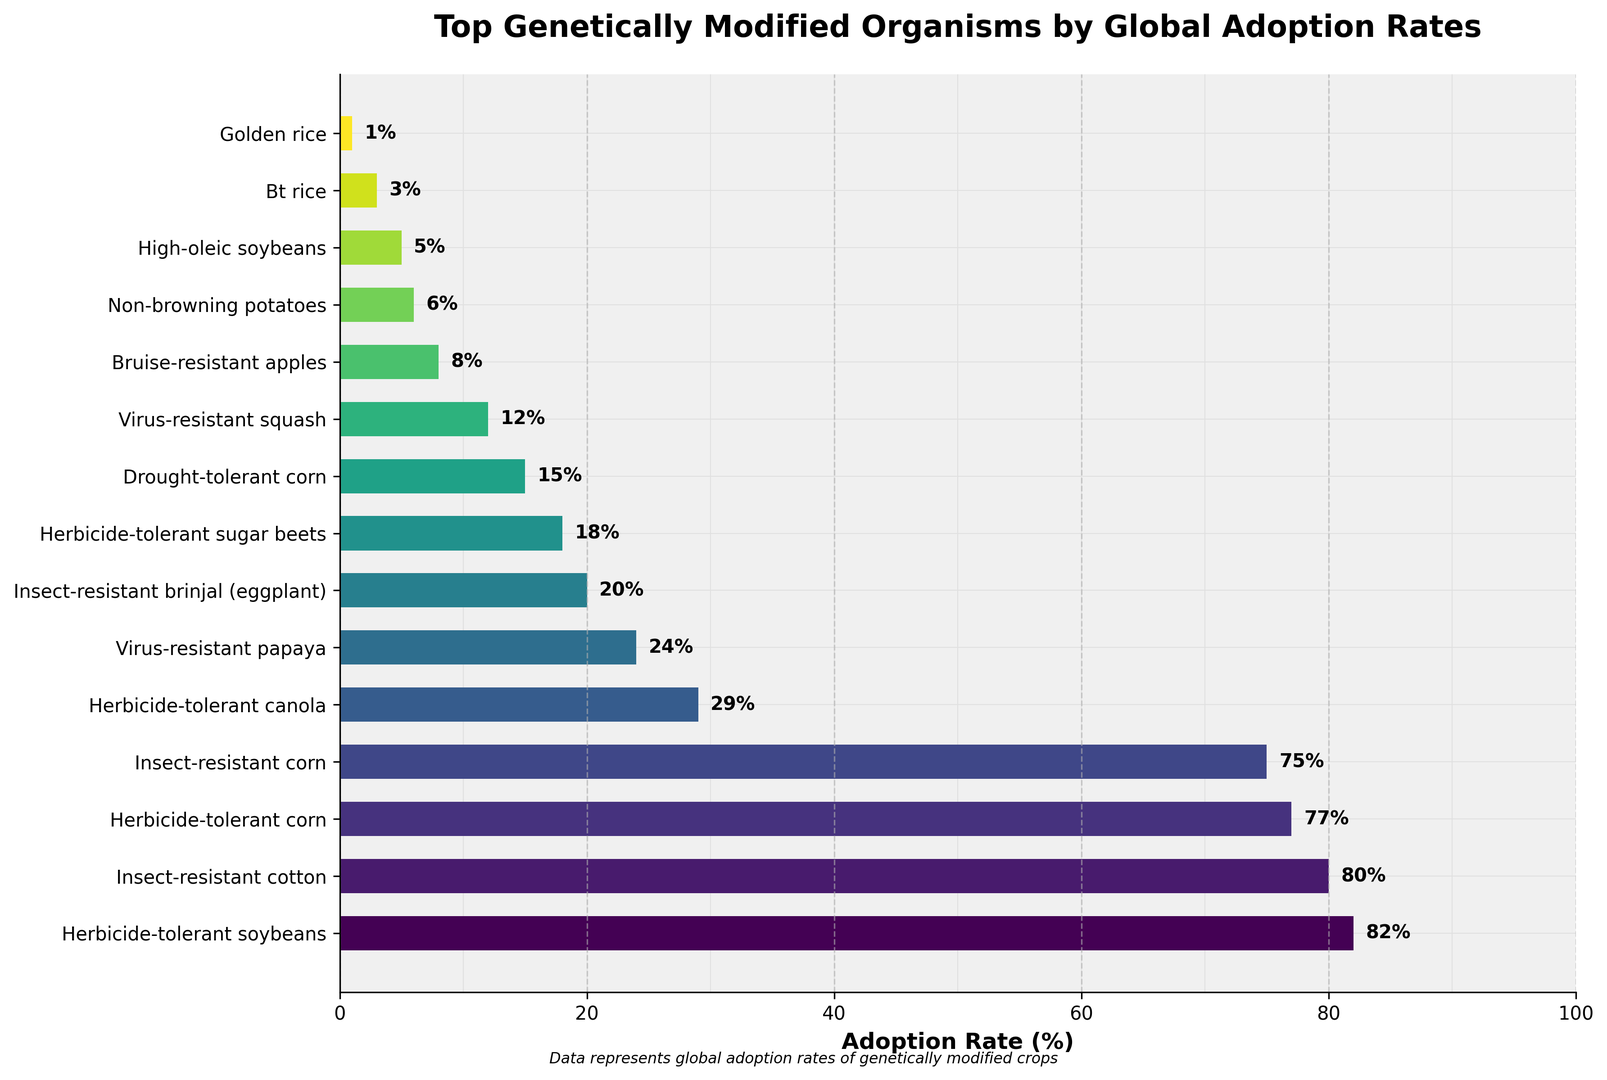Which genetically modified organism has the highest adoption rate? Look at the bar with the greatest length and highest value on the x-axis. In this case, it's the bar labeled "Herbicide-tolerant soybeans" with an adoption rate of 82%.
Answer: Herbicide-tolerant soybeans What's the difference in adoption rates between the top-ranked and bottom-ranked organisms? Find the adoption rates of the highest and lowest organisms: 82% for Herbicide-tolerant soybeans and 1% for Golden rice. Subtract the latter from the former: 82% - 1% = 81%.
Answer: 81% Which type of genetically modified corn has a higher adoption rate, insect-resistant or drought-tolerant? Compare the bars labeled "Insect-resistant corn" and "Drought-tolerant corn" to see their adoption rates, which are 75% and 15%, respectively. "Insect-resistant corn" has a higher adoption rate.
Answer: Insect-resistant corn How many organisms have an adoption rate of 20% or higher? Count the number of bars whose adoption rates are 20% or higher. They are Herbicide-tolerant soybeans (82%), Insect-resistant cotton (80%), Herbicide-tolerant corn (77%), Insect-resistant corn (75%), Herbicide-tolerant canola (29%), Virus-resistant papaya (24%), and Insect-resistant brinjal (eggplant) (20%). This makes 7 organisms.
Answer: 7 What is the combined adoption rate of the two least adopted genetically modified organisms? Find the adoption rates of the two organisms with the smallest values: Golden rice (1%) and Bt rice (3%). Add these rates together: 1% + 3% = 4%.
Answer: 4% Which organism has the shortest bar in the plot? Look for the bar with the smallest length on the horizontal axis. The bar for Golden rice is the shortest, with an adoption rate of 1%.
Answer: Golden rice Are there any genetically modified organisms with the same adoption rate? If so, which ones? Check if any bars have the same length on the chart. In the data, there appear to be no organisms with exactly the same adoption rate. Thus, no organisms share the same adoption rate.
Answer: No How does the adoption rate of Virus-resistant papaya compare to that of Non-browning potatoes? Compare the lengths of the bars for Virus-resistant papaya (24%) and Non-browning potatoes (6%). Virus-resistant papaya has a higher adoption rate.
Answer: Virus-resistant papaya has a higher adoption rate What is the average adoption rate of the top 5 genetically modified organisms? Sum the adoption rates of the top 5 organisms: Herbicide-tolerant soybeans (82%), Insect-resistant cotton (80%), Herbicide-tolerant corn (77%), Insect-resistant corn (75%), and Herbicide-tolerant canola (29%). Add these rates: 82 + 80 + 77 + 75 + 29 = 343. Divide by 5 to find the average: 343 / 5 = 68.6%.
Answer: 68.6% 